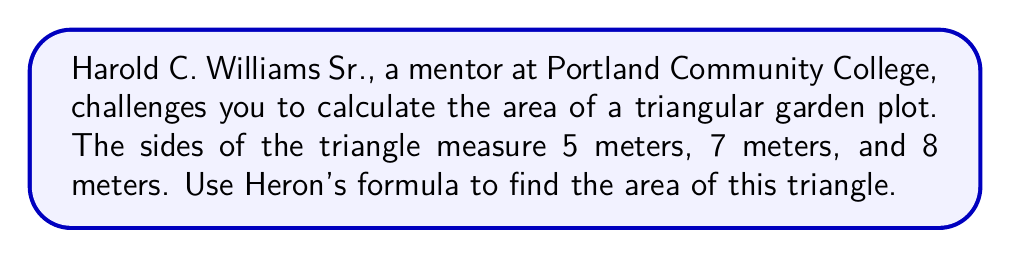Can you solve this math problem? Let's approach this step-by-step using Heron's formula:

1) Heron's formula states that the area $A$ of a triangle with sides $a$, $b$, and $c$ is:

   $$A = \sqrt{s(s-a)(s-b)(s-c)}$$

   where $s$ is the semi-perimeter: $s = \frac{a+b+c}{2}$

2) We have $a = 5$, $b = 7$, and $c = 8$. Let's calculate $s$:

   $$s = \frac{5+7+8}{2} = \frac{20}{2} = 10$$

3) Now, let's substitute these values into Heron's formula:

   $$A = \sqrt{10(10-5)(10-7)(10-8)}$$

4) Simplify inside the parentheses:

   $$A = \sqrt{10 \cdot 5 \cdot 3 \cdot 2}$$

5) Multiply the numbers under the square root:

   $$A = \sqrt{300}$$

6) Simplify the square root:

   $$A = 10\sqrt{3}$$

Therefore, the area of the triangular garden plot is $10\sqrt{3}$ square meters.
Answer: $10\sqrt{3}$ m² 